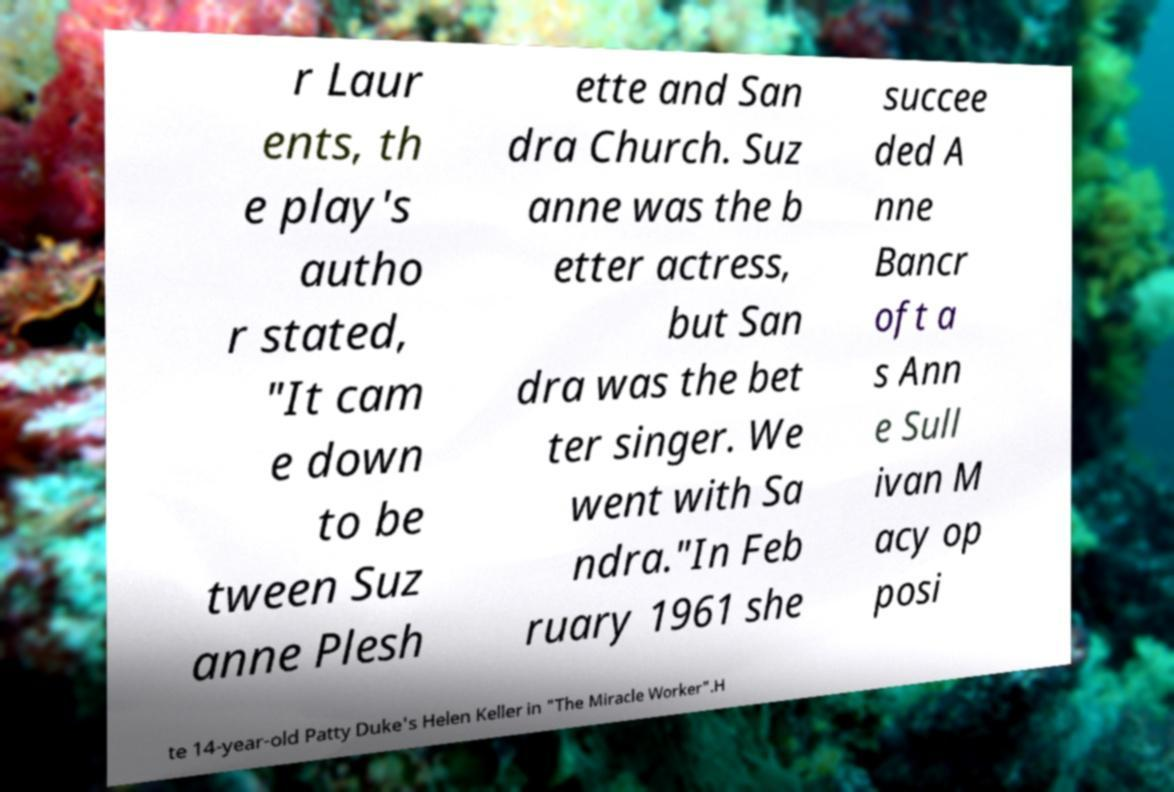Please read and relay the text visible in this image. What does it say? r Laur ents, th e play's autho r stated, "It cam e down to be tween Suz anne Plesh ette and San dra Church. Suz anne was the b etter actress, but San dra was the bet ter singer. We went with Sa ndra."In Feb ruary 1961 she succee ded A nne Bancr oft a s Ann e Sull ivan M acy op posi te 14-year-old Patty Duke's Helen Keller in "The Miracle Worker".H 